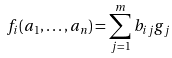Convert formula to latex. <formula><loc_0><loc_0><loc_500><loc_500>f _ { i } ( a _ { 1 } , \dots , a _ { n } ) = \sum _ { j = 1 } ^ { m } b _ { i j } g _ { j }</formula> 